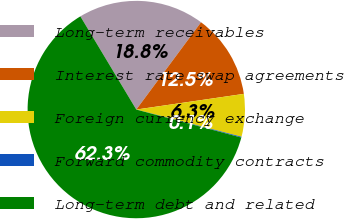<chart> <loc_0><loc_0><loc_500><loc_500><pie_chart><fcel>Long-term receivables<fcel>Interest rate swap agreements<fcel>Foreign currency exchange<fcel>Forward commodity contracts<fcel>Long-term debt and related<nl><fcel>18.76%<fcel>12.54%<fcel>6.33%<fcel>0.12%<fcel>62.26%<nl></chart> 